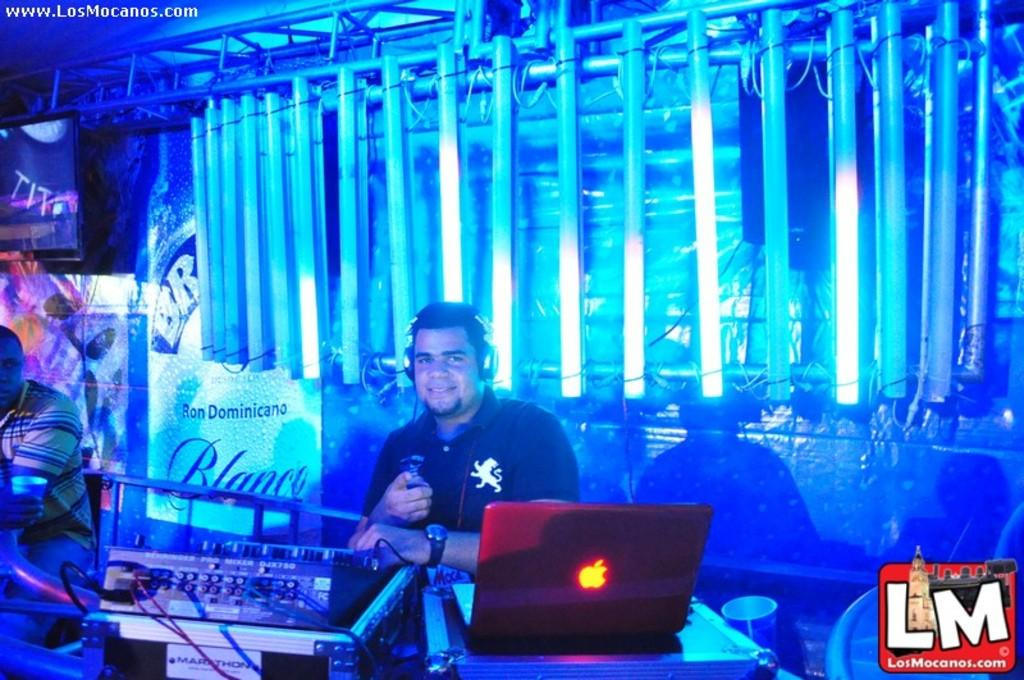<image>
Relay a brief, clear account of the picture shown. an LM logo at the bottom of a club 